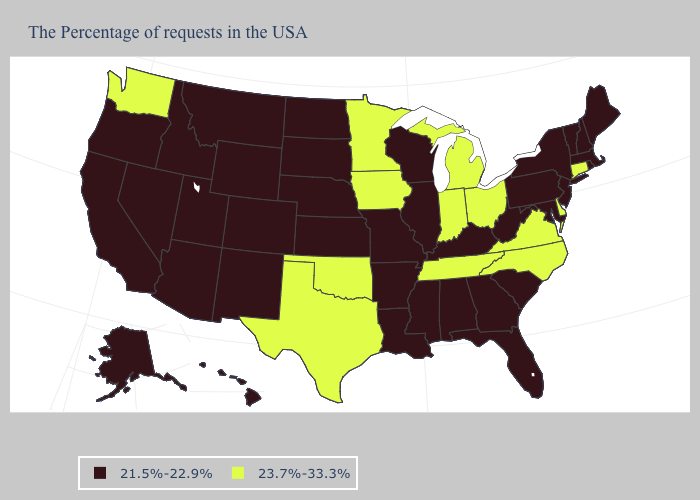Among the states that border Montana , which have the highest value?
Answer briefly. South Dakota, North Dakota, Wyoming, Idaho. What is the value of Louisiana?
Quick response, please. 21.5%-22.9%. What is the value of Connecticut?
Keep it brief. 23.7%-33.3%. What is the value of Illinois?
Concise answer only. 21.5%-22.9%. What is the value of North Carolina?
Concise answer only. 23.7%-33.3%. What is the highest value in states that border Minnesota?
Give a very brief answer. 23.7%-33.3%. Name the states that have a value in the range 23.7%-33.3%?
Concise answer only. Connecticut, Delaware, Virginia, North Carolina, Ohio, Michigan, Indiana, Tennessee, Minnesota, Iowa, Oklahoma, Texas, Washington. Does Utah have the lowest value in the USA?
Short answer required. Yes. How many symbols are there in the legend?
Concise answer only. 2. Which states have the lowest value in the MidWest?
Write a very short answer. Wisconsin, Illinois, Missouri, Kansas, Nebraska, South Dakota, North Dakota. What is the value of Utah?
Give a very brief answer. 21.5%-22.9%. Does the first symbol in the legend represent the smallest category?
Answer briefly. Yes. Which states have the highest value in the USA?
Be succinct. Connecticut, Delaware, Virginia, North Carolina, Ohio, Michigan, Indiana, Tennessee, Minnesota, Iowa, Oklahoma, Texas, Washington. Name the states that have a value in the range 21.5%-22.9%?
Concise answer only. Maine, Massachusetts, Rhode Island, New Hampshire, Vermont, New York, New Jersey, Maryland, Pennsylvania, South Carolina, West Virginia, Florida, Georgia, Kentucky, Alabama, Wisconsin, Illinois, Mississippi, Louisiana, Missouri, Arkansas, Kansas, Nebraska, South Dakota, North Dakota, Wyoming, Colorado, New Mexico, Utah, Montana, Arizona, Idaho, Nevada, California, Oregon, Alaska, Hawaii. Name the states that have a value in the range 21.5%-22.9%?
Short answer required. Maine, Massachusetts, Rhode Island, New Hampshire, Vermont, New York, New Jersey, Maryland, Pennsylvania, South Carolina, West Virginia, Florida, Georgia, Kentucky, Alabama, Wisconsin, Illinois, Mississippi, Louisiana, Missouri, Arkansas, Kansas, Nebraska, South Dakota, North Dakota, Wyoming, Colorado, New Mexico, Utah, Montana, Arizona, Idaho, Nevada, California, Oregon, Alaska, Hawaii. 